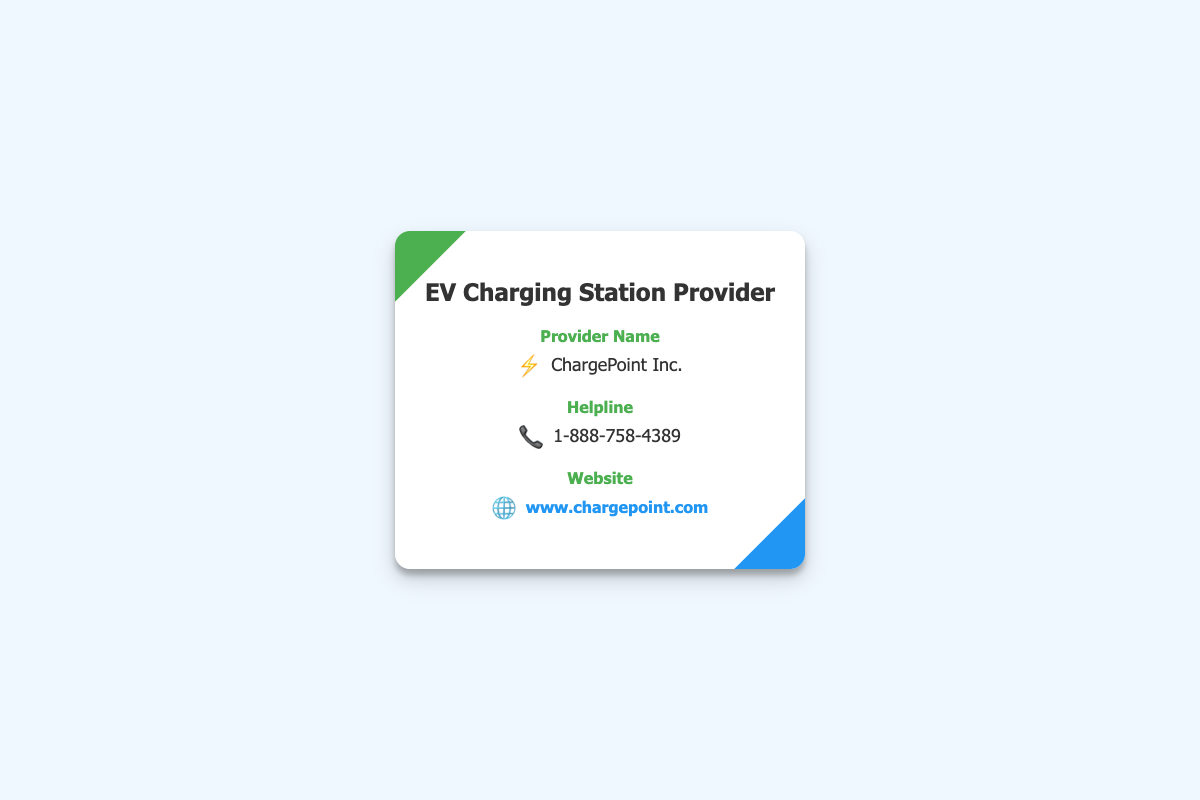What is the provider's name? The provider's name is displayed prominently in the document.
Answer: ChargePoint Inc What is the helpline number? The helpline number is clearly indicated next to the label for helpline.
Answer: 1-888-758-4389 What is the website URL? The website URL is provided as a hyperlink at the bottom of the card.
Answer: www.chargepoint.com What type of document is this? The document is a business card, which typically contains contact information.
Answer: Business card What icon represents the provider's name? The icon next to the provider's name signifies electric charging and is a common symbol for EVs.
Answer: ⚡ What color scheme is used in the card? The card uses two primary colors, green and blue, which are significant in branding for eco-friendly services.
Answer: Green and blue How is the website presented in the document? The website URL is presented as a clickable link making it user-friendly for quick access.
Answer: Clickable link What is the title of the card? The title is a key feature of the document that indicates the content focus.
Answer: EV Charging Station Provider 